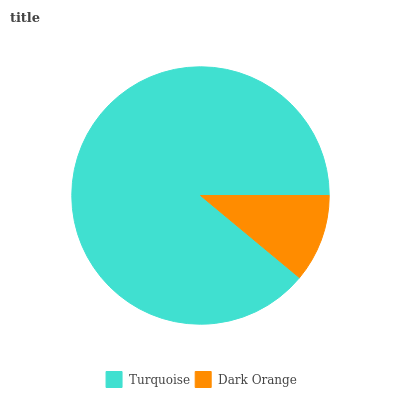Is Dark Orange the minimum?
Answer yes or no. Yes. Is Turquoise the maximum?
Answer yes or no. Yes. Is Dark Orange the maximum?
Answer yes or no. No. Is Turquoise greater than Dark Orange?
Answer yes or no. Yes. Is Dark Orange less than Turquoise?
Answer yes or no. Yes. Is Dark Orange greater than Turquoise?
Answer yes or no. No. Is Turquoise less than Dark Orange?
Answer yes or no. No. Is Turquoise the high median?
Answer yes or no. Yes. Is Dark Orange the low median?
Answer yes or no. Yes. Is Dark Orange the high median?
Answer yes or no. No. Is Turquoise the low median?
Answer yes or no. No. 